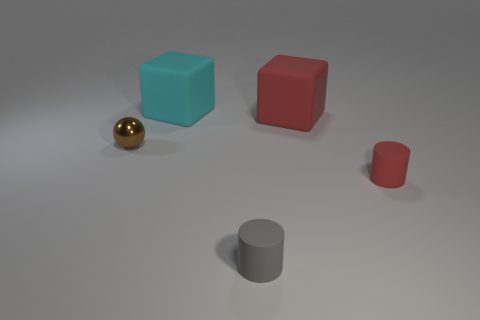Add 3 large cyan objects. How many objects exist? 8 Subtract 1 gray cylinders. How many objects are left? 4 Subtract all cubes. How many objects are left? 3 Subtract all large brown things. Subtract all rubber things. How many objects are left? 1 Add 1 large cyan rubber cubes. How many large cyan rubber cubes are left? 2 Add 5 small gray shiny cylinders. How many small gray shiny cylinders exist? 5 